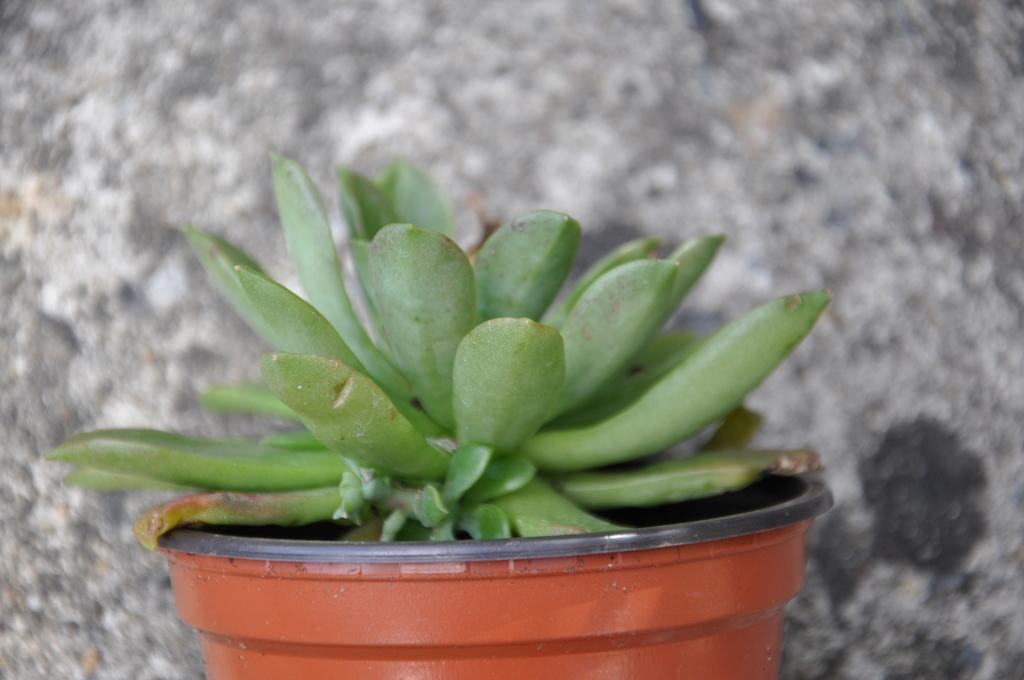How would you summarize this image in a sentence or two? In the center of the image, we can see a plant in the pot and in the background, there is a wall. 